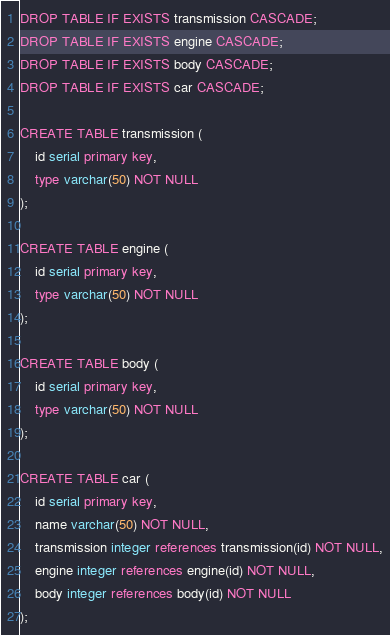Convert code to text. <code><loc_0><loc_0><loc_500><loc_500><_SQL_>DROP TABLE IF EXISTS transmission CASCADE;
DROP TABLE IF EXISTS engine CASCADE;
DROP TABLE IF EXISTS body CASCADE;
DROP TABLE IF EXISTS car CASCADE;

CREATE TABLE transmission (
	id serial primary key,
	type varchar(50) NOT NULL
);

CREATE TABLE engine (
	id serial primary key,
	type varchar(50) NOT NULL
);

CREATE TABLE body (
	id serial primary key,
	type varchar(50) NOT NULL
);

CREATE TABLE car (
	id serial primary key,
	name varchar(50) NOT NULL,
	transmission integer references transmission(id) NOT NULL,
	engine integer references engine(id) NOT NULL,
	body integer references body(id) NOT NULL
);
</code> 